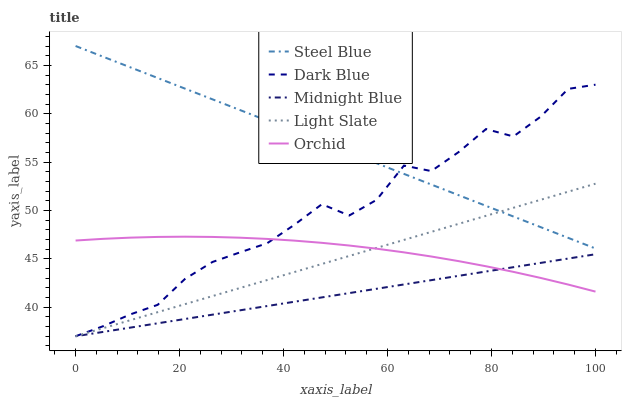Does Midnight Blue have the minimum area under the curve?
Answer yes or no. Yes. Does Steel Blue have the maximum area under the curve?
Answer yes or no. Yes. Does Dark Blue have the minimum area under the curve?
Answer yes or no. No. Does Dark Blue have the maximum area under the curve?
Answer yes or no. No. Is Midnight Blue the smoothest?
Answer yes or no. Yes. Is Dark Blue the roughest?
Answer yes or no. Yes. Is Orchid the smoothest?
Answer yes or no. No. Is Orchid the roughest?
Answer yes or no. No. Does Light Slate have the lowest value?
Answer yes or no. Yes. Does Orchid have the lowest value?
Answer yes or no. No. Does Steel Blue have the highest value?
Answer yes or no. Yes. Does Dark Blue have the highest value?
Answer yes or no. No. Is Orchid less than Steel Blue?
Answer yes or no. Yes. Is Steel Blue greater than Midnight Blue?
Answer yes or no. Yes. Does Steel Blue intersect Dark Blue?
Answer yes or no. Yes. Is Steel Blue less than Dark Blue?
Answer yes or no. No. Is Steel Blue greater than Dark Blue?
Answer yes or no. No. Does Orchid intersect Steel Blue?
Answer yes or no. No. 